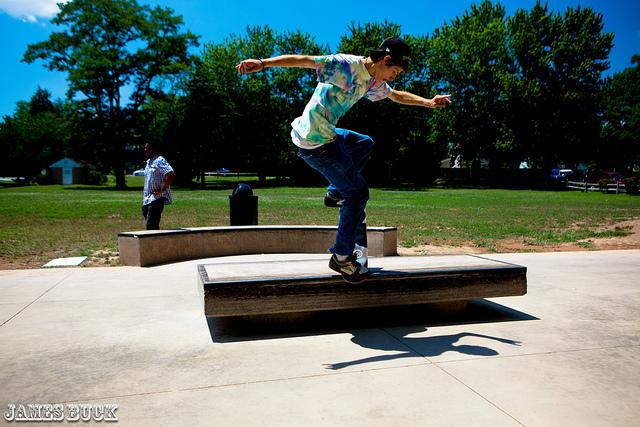In which space is this person boarding? park 